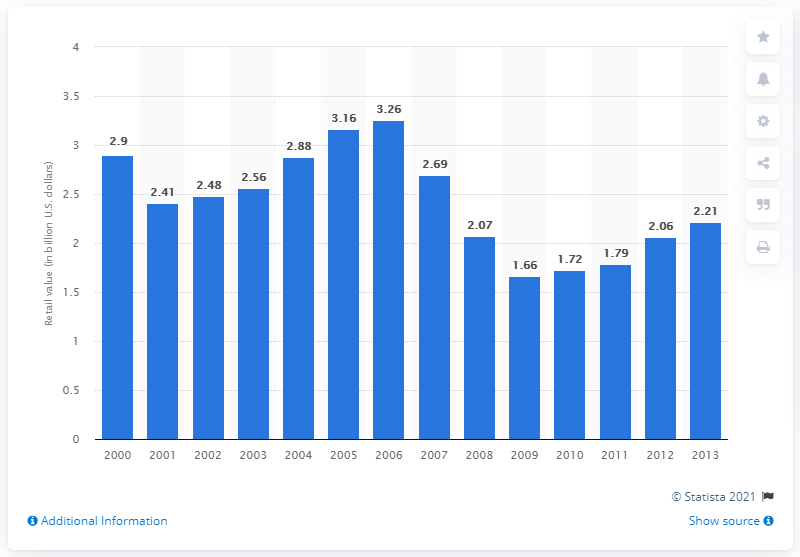Point out several critical features in this image. In the year 2005, a total of 3.2 billion U.S. dollars worth of outboard engines were sold. 